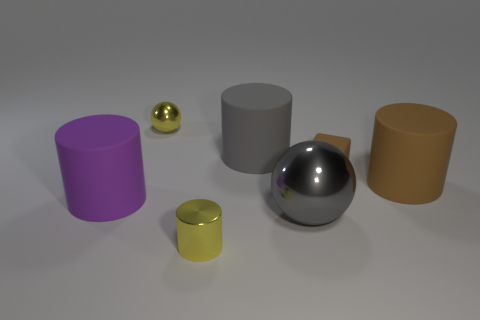What number of big matte cylinders are the same color as the matte cube?
Your answer should be very brief. 1. Do the shiny object that is to the left of the small metallic cylinder and the small shiny cylinder have the same color?
Provide a succinct answer. Yes. What material is the yellow thing that is to the right of the yellow object behind the matte thing that is on the left side of the small cylinder?
Offer a terse response. Metal. What number of other things are the same size as the gray shiny thing?
Your answer should be compact. 3. The tiny metal cylinder is what color?
Your response must be concise. Yellow. What number of shiny things are either big brown cylinders or balls?
Your answer should be compact. 2. There is a rubber object on the left side of the tiny object in front of the shiny object to the right of the small yellow metallic cylinder; what size is it?
Make the answer very short. Large. There is a rubber object that is both on the left side of the small brown rubber object and in front of the gray matte object; what is its size?
Provide a succinct answer. Large. Do the ball in front of the big purple cylinder and the object that is behind the gray rubber thing have the same color?
Your response must be concise. No. What number of rubber cylinders are behind the purple rubber cylinder?
Offer a very short reply. 2. 